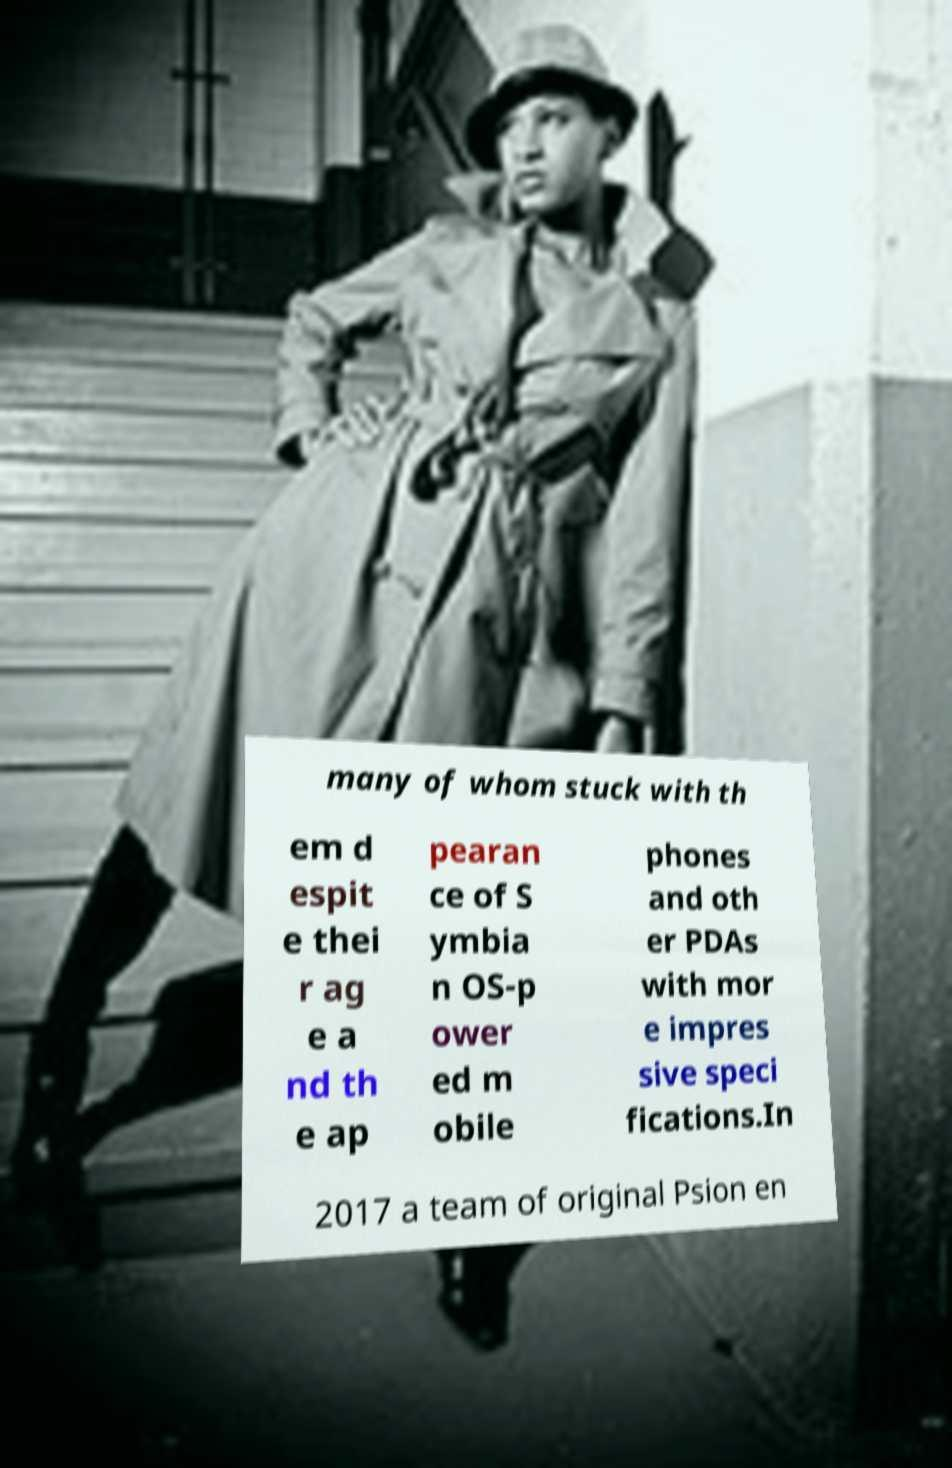I need the written content from this picture converted into text. Can you do that? many of whom stuck with th em d espit e thei r ag e a nd th e ap pearan ce of S ymbia n OS-p ower ed m obile phones and oth er PDAs with mor e impres sive speci fications.In 2017 a team of original Psion en 